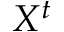Convert formula to latex. <formula><loc_0><loc_0><loc_500><loc_500>X ^ { t }</formula> 